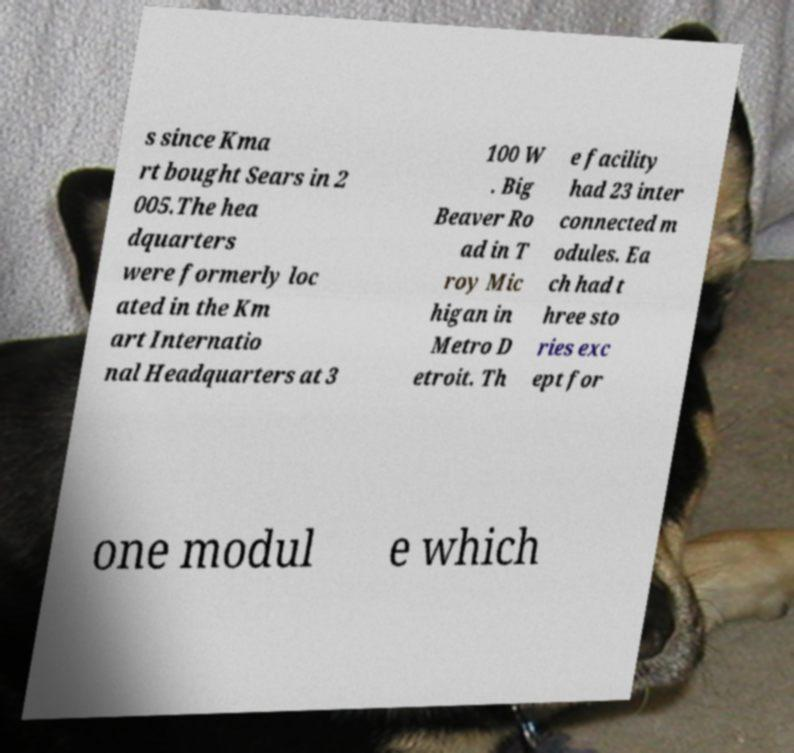Please identify and transcribe the text found in this image. s since Kma rt bought Sears in 2 005.The hea dquarters were formerly loc ated in the Km art Internatio nal Headquarters at 3 100 W . Big Beaver Ro ad in T roy Mic higan in Metro D etroit. Th e facility had 23 inter connected m odules. Ea ch had t hree sto ries exc ept for one modul e which 